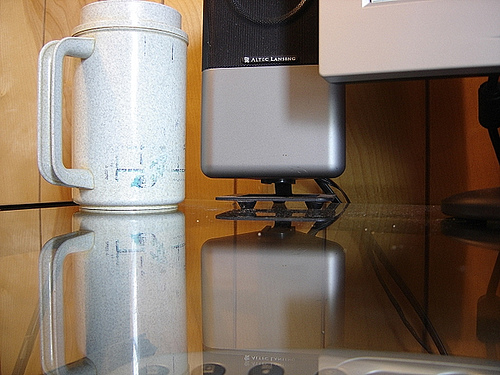<image>
Is the speaker in front of the monitor? No. The speaker is not in front of the monitor. The spatial positioning shows a different relationship between these objects. 